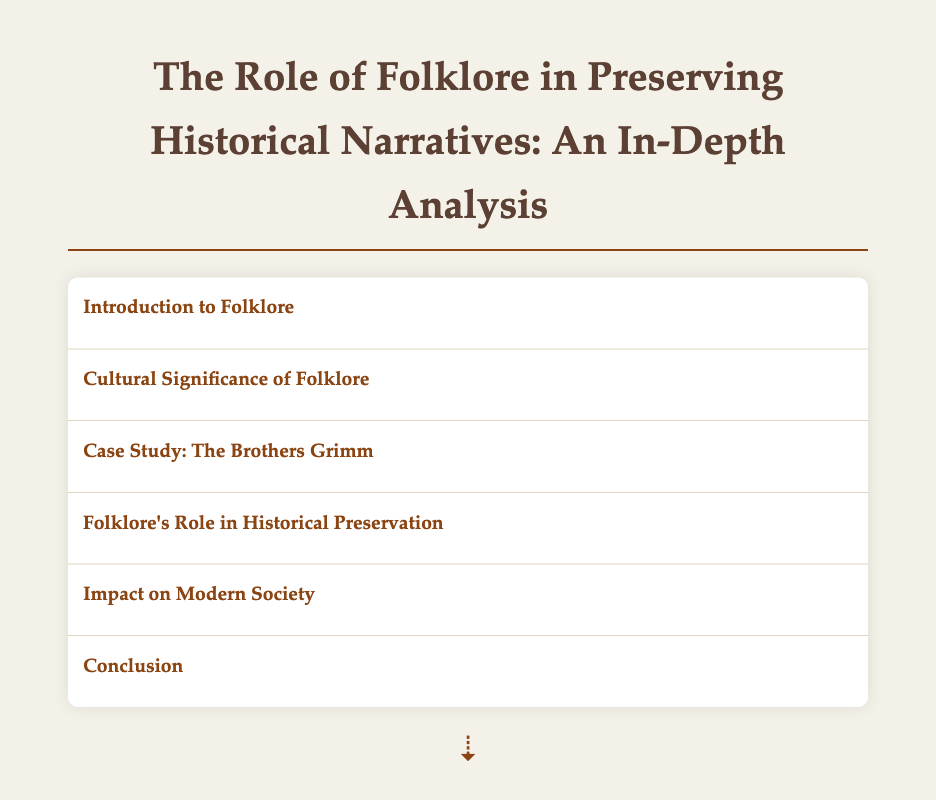What is the title of the document? The title of the document is stated at the beginning.
Answer: The Role of Folklore in Preserving Historical Narratives: An In-Depth Analysis Who collected and published German folktales? The document identifies Jacob and Wilhelm Grimm as the collectors and publishers.
Answer: Jacob and Wilhelm Grimm What does folklore encompass? The introduction provides a definition of folklore.
Answer: Traditional beliefs, customs, stories, songs, and practices How does folklore act as a lens for anthropologists? The document explains the significance of folklore in examining cultural identity.
Answer: It captures the collective memory of communities What tradition preserves genealogies and histories in African culture? The document mentions a specific tradition related to storytelling in Africa.
Answer: Griot tradition What is one modern way folklore is revitalized in society? The document lists an example of how folklore continues to influence modern society.
Answer: Festivals What role does folklore play in historical preservation? The document details how folklore operates as a means for transmitting cultural memories.
Answer: Transmitting important events and cultural memories What is the impact of folklore on community identity? The document explains how folklore contributes to community identity and resilience.
Answer: Fosters community identity and resilience What is emphasized as crucial for cultural anthropology? The document concludes with the importance of one specific interplay.
Answer: The interplay between folklore and historical narrative 